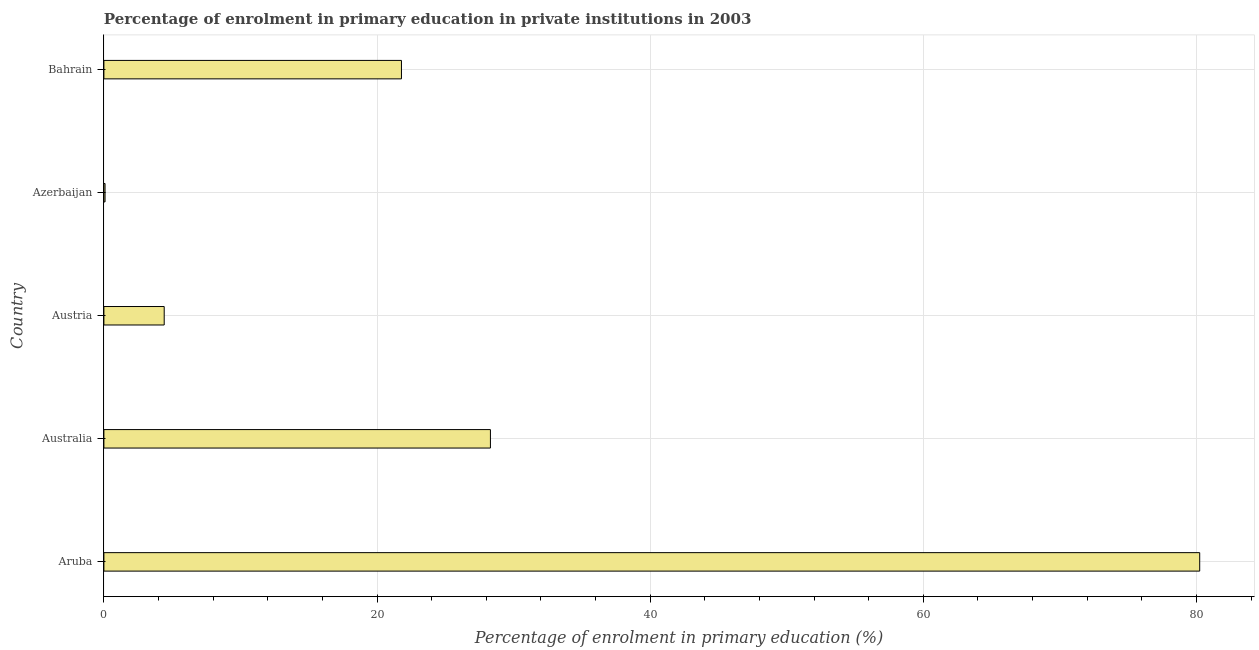Does the graph contain grids?
Provide a short and direct response. Yes. What is the title of the graph?
Your response must be concise. Percentage of enrolment in primary education in private institutions in 2003. What is the label or title of the X-axis?
Provide a succinct answer. Percentage of enrolment in primary education (%). What is the label or title of the Y-axis?
Offer a very short reply. Country. What is the enrolment percentage in primary education in Bahrain?
Provide a short and direct response. 21.79. Across all countries, what is the maximum enrolment percentage in primary education?
Give a very brief answer. 80.24. Across all countries, what is the minimum enrolment percentage in primary education?
Give a very brief answer. 0.08. In which country was the enrolment percentage in primary education maximum?
Your response must be concise. Aruba. In which country was the enrolment percentage in primary education minimum?
Offer a terse response. Azerbaijan. What is the sum of the enrolment percentage in primary education?
Offer a terse response. 134.83. What is the difference between the enrolment percentage in primary education in Austria and Bahrain?
Make the answer very short. -17.37. What is the average enrolment percentage in primary education per country?
Give a very brief answer. 26.96. What is the median enrolment percentage in primary education?
Offer a very short reply. 21.79. What is the ratio of the enrolment percentage in primary education in Australia to that in Azerbaijan?
Your answer should be very brief. 335.02. Is the enrolment percentage in primary education in Australia less than that in Bahrain?
Provide a short and direct response. No. What is the difference between the highest and the second highest enrolment percentage in primary education?
Offer a terse response. 51.93. What is the difference between the highest and the lowest enrolment percentage in primary education?
Offer a terse response. 80.15. In how many countries, is the enrolment percentage in primary education greater than the average enrolment percentage in primary education taken over all countries?
Give a very brief answer. 2. How many bars are there?
Your answer should be very brief. 5. How many countries are there in the graph?
Give a very brief answer. 5. Are the values on the major ticks of X-axis written in scientific E-notation?
Keep it short and to the point. No. What is the Percentage of enrolment in primary education (%) in Aruba?
Offer a very short reply. 80.24. What is the Percentage of enrolment in primary education (%) of Australia?
Provide a short and direct response. 28.3. What is the Percentage of enrolment in primary education (%) in Austria?
Offer a very short reply. 4.42. What is the Percentage of enrolment in primary education (%) in Azerbaijan?
Your answer should be very brief. 0.08. What is the Percentage of enrolment in primary education (%) of Bahrain?
Your answer should be very brief. 21.79. What is the difference between the Percentage of enrolment in primary education (%) in Aruba and Australia?
Provide a succinct answer. 51.93. What is the difference between the Percentage of enrolment in primary education (%) in Aruba and Austria?
Provide a succinct answer. 75.82. What is the difference between the Percentage of enrolment in primary education (%) in Aruba and Azerbaijan?
Make the answer very short. 80.15. What is the difference between the Percentage of enrolment in primary education (%) in Aruba and Bahrain?
Provide a short and direct response. 58.45. What is the difference between the Percentage of enrolment in primary education (%) in Australia and Austria?
Provide a succinct answer. 23.89. What is the difference between the Percentage of enrolment in primary education (%) in Australia and Azerbaijan?
Your response must be concise. 28.22. What is the difference between the Percentage of enrolment in primary education (%) in Australia and Bahrain?
Provide a succinct answer. 6.51. What is the difference between the Percentage of enrolment in primary education (%) in Austria and Azerbaijan?
Keep it short and to the point. 4.33. What is the difference between the Percentage of enrolment in primary education (%) in Austria and Bahrain?
Provide a short and direct response. -17.37. What is the difference between the Percentage of enrolment in primary education (%) in Azerbaijan and Bahrain?
Make the answer very short. -21.7. What is the ratio of the Percentage of enrolment in primary education (%) in Aruba to that in Australia?
Offer a very short reply. 2.83. What is the ratio of the Percentage of enrolment in primary education (%) in Aruba to that in Austria?
Ensure brevity in your answer.  18.17. What is the ratio of the Percentage of enrolment in primary education (%) in Aruba to that in Azerbaijan?
Make the answer very short. 949.77. What is the ratio of the Percentage of enrolment in primary education (%) in Aruba to that in Bahrain?
Provide a succinct answer. 3.68. What is the ratio of the Percentage of enrolment in primary education (%) in Australia to that in Austria?
Provide a succinct answer. 6.41. What is the ratio of the Percentage of enrolment in primary education (%) in Australia to that in Azerbaijan?
Give a very brief answer. 335.02. What is the ratio of the Percentage of enrolment in primary education (%) in Australia to that in Bahrain?
Your response must be concise. 1.3. What is the ratio of the Percentage of enrolment in primary education (%) in Austria to that in Azerbaijan?
Your response must be concise. 52.27. What is the ratio of the Percentage of enrolment in primary education (%) in Austria to that in Bahrain?
Offer a terse response. 0.2. What is the ratio of the Percentage of enrolment in primary education (%) in Azerbaijan to that in Bahrain?
Offer a very short reply. 0. 